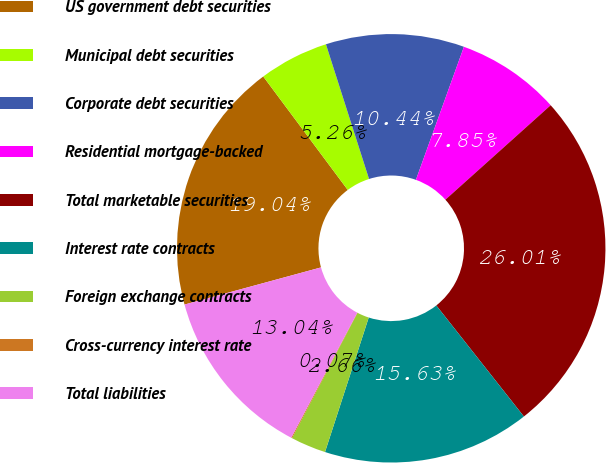<chart> <loc_0><loc_0><loc_500><loc_500><pie_chart><fcel>US government debt securities<fcel>Municipal debt securities<fcel>Corporate debt securities<fcel>Residential mortgage-backed<fcel>Total marketable securities<fcel>Interest rate contracts<fcel>Foreign exchange contracts<fcel>Cross-currency interest rate<fcel>Total liabilities<nl><fcel>19.04%<fcel>5.26%<fcel>10.44%<fcel>7.85%<fcel>26.01%<fcel>15.63%<fcel>2.66%<fcel>0.07%<fcel>13.04%<nl></chart> 